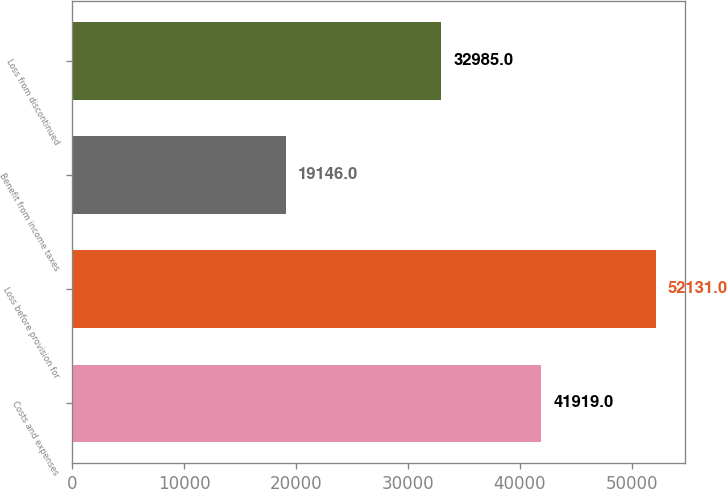Convert chart. <chart><loc_0><loc_0><loc_500><loc_500><bar_chart><fcel>Costs and expenses<fcel>Loss before provision for<fcel>Benefit from income taxes<fcel>Loss from discontinued<nl><fcel>41919<fcel>52131<fcel>19146<fcel>32985<nl></chart> 